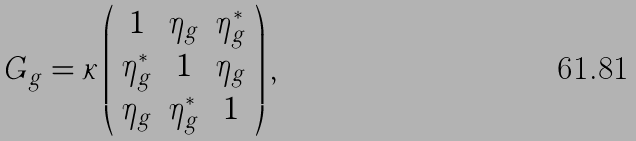Convert formula to latex. <formula><loc_0><loc_0><loc_500><loc_500>G _ { g } = \kappa \left ( \begin{array} { c c c } 1 & \eta _ { g } & \eta _ { g } ^ { * } \\ \eta _ { g } ^ { * } & 1 & \eta _ { g } \\ \eta _ { g } & \eta _ { g } ^ { * } & 1 \end{array} \right ) ,</formula> 